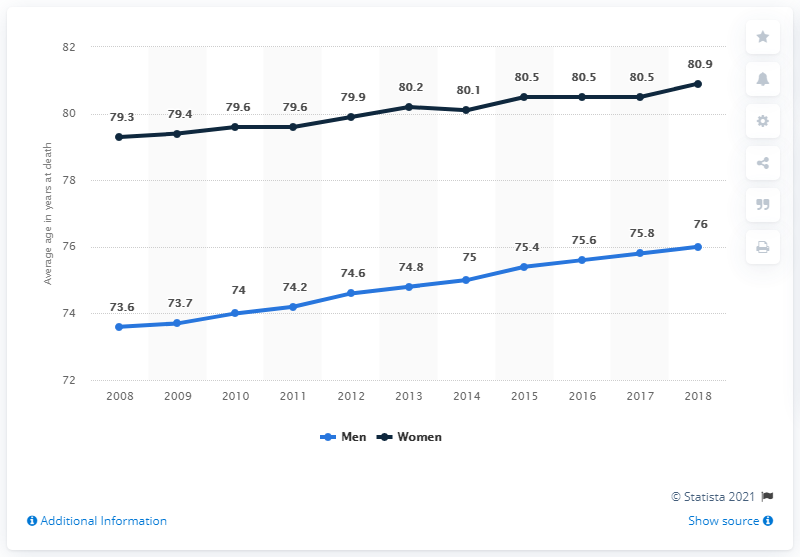List a handful of essential elements in this visual. The maximum age at death of men is generally higher than the minimum age at death of women. The average age of men who died in the Netherlands in 2013 was 74.8 years old. 